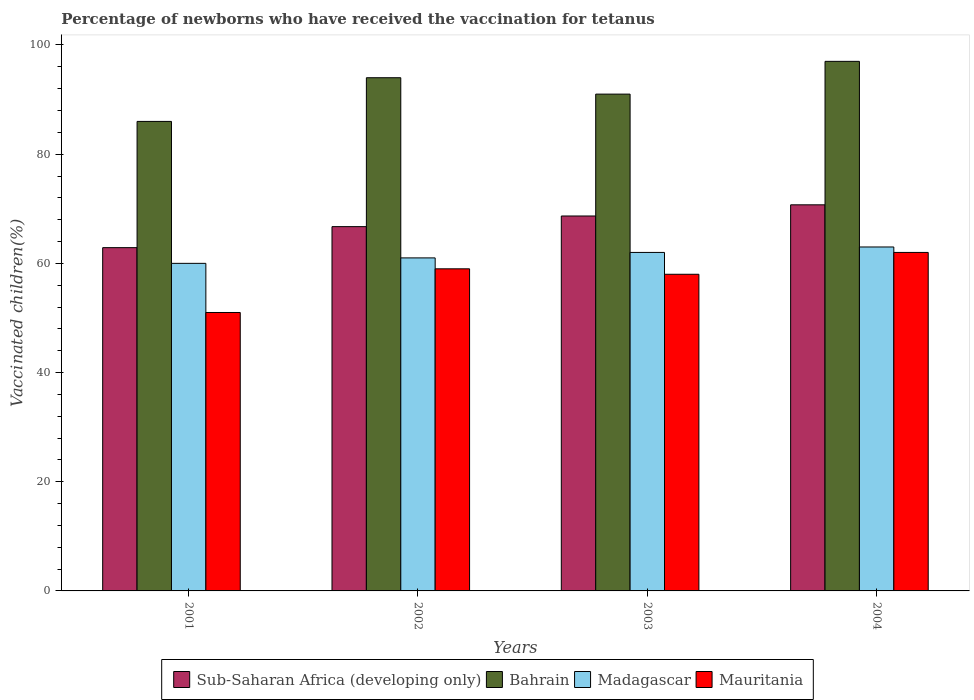How many different coloured bars are there?
Offer a very short reply. 4. How many groups of bars are there?
Offer a terse response. 4. Are the number of bars per tick equal to the number of legend labels?
Your response must be concise. Yes. Are the number of bars on each tick of the X-axis equal?
Offer a very short reply. Yes. How many bars are there on the 1st tick from the left?
Your response must be concise. 4. What is the percentage of vaccinated children in Mauritania in 2004?
Keep it short and to the point. 62. Across all years, what is the maximum percentage of vaccinated children in Madagascar?
Your answer should be compact. 63. Across all years, what is the minimum percentage of vaccinated children in Madagascar?
Your response must be concise. 60. In which year was the percentage of vaccinated children in Sub-Saharan Africa (developing only) maximum?
Your answer should be compact. 2004. What is the total percentage of vaccinated children in Madagascar in the graph?
Your answer should be compact. 246. What is the difference between the percentage of vaccinated children in Sub-Saharan Africa (developing only) in 2001 and that in 2003?
Your response must be concise. -5.8. What is the difference between the percentage of vaccinated children in Bahrain in 2003 and the percentage of vaccinated children in Madagascar in 2001?
Provide a succinct answer. 31. What is the average percentage of vaccinated children in Bahrain per year?
Ensure brevity in your answer.  92. In the year 2003, what is the difference between the percentage of vaccinated children in Sub-Saharan Africa (developing only) and percentage of vaccinated children in Mauritania?
Give a very brief answer. 10.68. What is the ratio of the percentage of vaccinated children in Sub-Saharan Africa (developing only) in 2002 to that in 2003?
Make the answer very short. 0.97. Is the percentage of vaccinated children in Bahrain in 2002 less than that in 2003?
Your answer should be very brief. No. Is the difference between the percentage of vaccinated children in Sub-Saharan Africa (developing only) in 2001 and 2004 greater than the difference between the percentage of vaccinated children in Mauritania in 2001 and 2004?
Make the answer very short. Yes. What is the difference between the highest and the lowest percentage of vaccinated children in Mauritania?
Offer a terse response. 11. In how many years, is the percentage of vaccinated children in Bahrain greater than the average percentage of vaccinated children in Bahrain taken over all years?
Your answer should be compact. 2. Is the sum of the percentage of vaccinated children in Madagascar in 2003 and 2004 greater than the maximum percentage of vaccinated children in Bahrain across all years?
Ensure brevity in your answer.  Yes. What does the 3rd bar from the left in 2001 represents?
Keep it short and to the point. Madagascar. What does the 4th bar from the right in 2002 represents?
Your answer should be very brief. Sub-Saharan Africa (developing only). Is it the case that in every year, the sum of the percentage of vaccinated children in Madagascar and percentage of vaccinated children in Bahrain is greater than the percentage of vaccinated children in Mauritania?
Give a very brief answer. Yes. Are all the bars in the graph horizontal?
Offer a terse response. No. What is the difference between two consecutive major ticks on the Y-axis?
Provide a succinct answer. 20. Are the values on the major ticks of Y-axis written in scientific E-notation?
Provide a succinct answer. No. Does the graph contain any zero values?
Make the answer very short. No. Does the graph contain grids?
Offer a terse response. No. How are the legend labels stacked?
Keep it short and to the point. Horizontal. What is the title of the graph?
Make the answer very short. Percentage of newborns who have received the vaccination for tetanus. Does "Kosovo" appear as one of the legend labels in the graph?
Provide a short and direct response. No. What is the label or title of the Y-axis?
Your answer should be very brief. Vaccinated children(%). What is the Vaccinated children(%) of Sub-Saharan Africa (developing only) in 2001?
Offer a terse response. 62.88. What is the Vaccinated children(%) in Madagascar in 2001?
Offer a terse response. 60. What is the Vaccinated children(%) of Sub-Saharan Africa (developing only) in 2002?
Your answer should be very brief. 66.73. What is the Vaccinated children(%) in Bahrain in 2002?
Your answer should be compact. 94. What is the Vaccinated children(%) of Madagascar in 2002?
Give a very brief answer. 61. What is the Vaccinated children(%) of Mauritania in 2002?
Provide a succinct answer. 59. What is the Vaccinated children(%) in Sub-Saharan Africa (developing only) in 2003?
Offer a very short reply. 68.68. What is the Vaccinated children(%) in Bahrain in 2003?
Your answer should be very brief. 91. What is the Vaccinated children(%) of Sub-Saharan Africa (developing only) in 2004?
Your answer should be compact. 70.72. What is the Vaccinated children(%) in Bahrain in 2004?
Provide a short and direct response. 97. What is the Vaccinated children(%) in Mauritania in 2004?
Give a very brief answer. 62. Across all years, what is the maximum Vaccinated children(%) in Sub-Saharan Africa (developing only)?
Your response must be concise. 70.72. Across all years, what is the maximum Vaccinated children(%) of Bahrain?
Provide a short and direct response. 97. Across all years, what is the minimum Vaccinated children(%) in Sub-Saharan Africa (developing only)?
Give a very brief answer. 62.88. Across all years, what is the minimum Vaccinated children(%) in Bahrain?
Provide a succinct answer. 86. Across all years, what is the minimum Vaccinated children(%) of Madagascar?
Provide a succinct answer. 60. Across all years, what is the minimum Vaccinated children(%) of Mauritania?
Provide a short and direct response. 51. What is the total Vaccinated children(%) of Sub-Saharan Africa (developing only) in the graph?
Provide a short and direct response. 269. What is the total Vaccinated children(%) of Bahrain in the graph?
Ensure brevity in your answer.  368. What is the total Vaccinated children(%) in Madagascar in the graph?
Keep it short and to the point. 246. What is the total Vaccinated children(%) in Mauritania in the graph?
Your answer should be compact. 230. What is the difference between the Vaccinated children(%) in Sub-Saharan Africa (developing only) in 2001 and that in 2002?
Ensure brevity in your answer.  -3.85. What is the difference between the Vaccinated children(%) of Sub-Saharan Africa (developing only) in 2001 and that in 2003?
Give a very brief answer. -5.8. What is the difference between the Vaccinated children(%) in Bahrain in 2001 and that in 2003?
Offer a very short reply. -5. What is the difference between the Vaccinated children(%) in Mauritania in 2001 and that in 2003?
Your answer should be very brief. -7. What is the difference between the Vaccinated children(%) of Sub-Saharan Africa (developing only) in 2001 and that in 2004?
Keep it short and to the point. -7.84. What is the difference between the Vaccinated children(%) of Madagascar in 2001 and that in 2004?
Provide a short and direct response. -3. What is the difference between the Vaccinated children(%) of Mauritania in 2001 and that in 2004?
Provide a succinct answer. -11. What is the difference between the Vaccinated children(%) in Sub-Saharan Africa (developing only) in 2002 and that in 2003?
Your response must be concise. -1.95. What is the difference between the Vaccinated children(%) in Bahrain in 2002 and that in 2003?
Give a very brief answer. 3. What is the difference between the Vaccinated children(%) of Madagascar in 2002 and that in 2003?
Your answer should be very brief. -1. What is the difference between the Vaccinated children(%) of Sub-Saharan Africa (developing only) in 2002 and that in 2004?
Your answer should be compact. -3.99. What is the difference between the Vaccinated children(%) of Sub-Saharan Africa (developing only) in 2003 and that in 2004?
Keep it short and to the point. -2.04. What is the difference between the Vaccinated children(%) of Bahrain in 2003 and that in 2004?
Your response must be concise. -6. What is the difference between the Vaccinated children(%) of Sub-Saharan Africa (developing only) in 2001 and the Vaccinated children(%) of Bahrain in 2002?
Give a very brief answer. -31.12. What is the difference between the Vaccinated children(%) in Sub-Saharan Africa (developing only) in 2001 and the Vaccinated children(%) in Madagascar in 2002?
Your answer should be compact. 1.88. What is the difference between the Vaccinated children(%) of Sub-Saharan Africa (developing only) in 2001 and the Vaccinated children(%) of Mauritania in 2002?
Offer a terse response. 3.88. What is the difference between the Vaccinated children(%) in Sub-Saharan Africa (developing only) in 2001 and the Vaccinated children(%) in Bahrain in 2003?
Keep it short and to the point. -28.12. What is the difference between the Vaccinated children(%) in Sub-Saharan Africa (developing only) in 2001 and the Vaccinated children(%) in Madagascar in 2003?
Give a very brief answer. 0.88. What is the difference between the Vaccinated children(%) of Sub-Saharan Africa (developing only) in 2001 and the Vaccinated children(%) of Mauritania in 2003?
Provide a short and direct response. 4.88. What is the difference between the Vaccinated children(%) of Sub-Saharan Africa (developing only) in 2001 and the Vaccinated children(%) of Bahrain in 2004?
Keep it short and to the point. -34.12. What is the difference between the Vaccinated children(%) in Sub-Saharan Africa (developing only) in 2001 and the Vaccinated children(%) in Madagascar in 2004?
Provide a succinct answer. -0.12. What is the difference between the Vaccinated children(%) of Sub-Saharan Africa (developing only) in 2001 and the Vaccinated children(%) of Mauritania in 2004?
Your answer should be very brief. 0.88. What is the difference between the Vaccinated children(%) of Bahrain in 2001 and the Vaccinated children(%) of Madagascar in 2004?
Make the answer very short. 23. What is the difference between the Vaccinated children(%) in Madagascar in 2001 and the Vaccinated children(%) in Mauritania in 2004?
Make the answer very short. -2. What is the difference between the Vaccinated children(%) of Sub-Saharan Africa (developing only) in 2002 and the Vaccinated children(%) of Bahrain in 2003?
Your response must be concise. -24.27. What is the difference between the Vaccinated children(%) of Sub-Saharan Africa (developing only) in 2002 and the Vaccinated children(%) of Madagascar in 2003?
Make the answer very short. 4.73. What is the difference between the Vaccinated children(%) in Sub-Saharan Africa (developing only) in 2002 and the Vaccinated children(%) in Mauritania in 2003?
Offer a very short reply. 8.73. What is the difference between the Vaccinated children(%) in Bahrain in 2002 and the Vaccinated children(%) in Madagascar in 2003?
Provide a short and direct response. 32. What is the difference between the Vaccinated children(%) of Madagascar in 2002 and the Vaccinated children(%) of Mauritania in 2003?
Keep it short and to the point. 3. What is the difference between the Vaccinated children(%) of Sub-Saharan Africa (developing only) in 2002 and the Vaccinated children(%) of Bahrain in 2004?
Your answer should be compact. -30.27. What is the difference between the Vaccinated children(%) of Sub-Saharan Africa (developing only) in 2002 and the Vaccinated children(%) of Madagascar in 2004?
Make the answer very short. 3.73. What is the difference between the Vaccinated children(%) of Sub-Saharan Africa (developing only) in 2002 and the Vaccinated children(%) of Mauritania in 2004?
Ensure brevity in your answer.  4.73. What is the difference between the Vaccinated children(%) in Bahrain in 2002 and the Vaccinated children(%) in Madagascar in 2004?
Your response must be concise. 31. What is the difference between the Vaccinated children(%) of Bahrain in 2002 and the Vaccinated children(%) of Mauritania in 2004?
Your answer should be very brief. 32. What is the difference between the Vaccinated children(%) of Sub-Saharan Africa (developing only) in 2003 and the Vaccinated children(%) of Bahrain in 2004?
Give a very brief answer. -28.32. What is the difference between the Vaccinated children(%) of Sub-Saharan Africa (developing only) in 2003 and the Vaccinated children(%) of Madagascar in 2004?
Offer a very short reply. 5.68. What is the difference between the Vaccinated children(%) in Sub-Saharan Africa (developing only) in 2003 and the Vaccinated children(%) in Mauritania in 2004?
Your response must be concise. 6.68. What is the difference between the Vaccinated children(%) of Bahrain in 2003 and the Vaccinated children(%) of Mauritania in 2004?
Keep it short and to the point. 29. What is the average Vaccinated children(%) in Sub-Saharan Africa (developing only) per year?
Provide a short and direct response. 67.25. What is the average Vaccinated children(%) in Bahrain per year?
Give a very brief answer. 92. What is the average Vaccinated children(%) in Madagascar per year?
Make the answer very short. 61.5. What is the average Vaccinated children(%) of Mauritania per year?
Provide a succinct answer. 57.5. In the year 2001, what is the difference between the Vaccinated children(%) in Sub-Saharan Africa (developing only) and Vaccinated children(%) in Bahrain?
Your answer should be very brief. -23.12. In the year 2001, what is the difference between the Vaccinated children(%) of Sub-Saharan Africa (developing only) and Vaccinated children(%) of Madagascar?
Provide a short and direct response. 2.88. In the year 2001, what is the difference between the Vaccinated children(%) in Sub-Saharan Africa (developing only) and Vaccinated children(%) in Mauritania?
Provide a succinct answer. 11.88. In the year 2001, what is the difference between the Vaccinated children(%) in Bahrain and Vaccinated children(%) in Mauritania?
Keep it short and to the point. 35. In the year 2002, what is the difference between the Vaccinated children(%) of Sub-Saharan Africa (developing only) and Vaccinated children(%) of Bahrain?
Offer a terse response. -27.27. In the year 2002, what is the difference between the Vaccinated children(%) in Sub-Saharan Africa (developing only) and Vaccinated children(%) in Madagascar?
Provide a succinct answer. 5.73. In the year 2002, what is the difference between the Vaccinated children(%) of Sub-Saharan Africa (developing only) and Vaccinated children(%) of Mauritania?
Keep it short and to the point. 7.73. In the year 2002, what is the difference between the Vaccinated children(%) of Bahrain and Vaccinated children(%) of Madagascar?
Offer a very short reply. 33. In the year 2002, what is the difference between the Vaccinated children(%) of Madagascar and Vaccinated children(%) of Mauritania?
Offer a terse response. 2. In the year 2003, what is the difference between the Vaccinated children(%) of Sub-Saharan Africa (developing only) and Vaccinated children(%) of Bahrain?
Provide a short and direct response. -22.32. In the year 2003, what is the difference between the Vaccinated children(%) of Sub-Saharan Africa (developing only) and Vaccinated children(%) of Madagascar?
Give a very brief answer. 6.68. In the year 2003, what is the difference between the Vaccinated children(%) in Sub-Saharan Africa (developing only) and Vaccinated children(%) in Mauritania?
Keep it short and to the point. 10.68. In the year 2003, what is the difference between the Vaccinated children(%) of Bahrain and Vaccinated children(%) of Madagascar?
Your answer should be very brief. 29. In the year 2003, what is the difference between the Vaccinated children(%) of Bahrain and Vaccinated children(%) of Mauritania?
Your response must be concise. 33. In the year 2003, what is the difference between the Vaccinated children(%) in Madagascar and Vaccinated children(%) in Mauritania?
Ensure brevity in your answer.  4. In the year 2004, what is the difference between the Vaccinated children(%) of Sub-Saharan Africa (developing only) and Vaccinated children(%) of Bahrain?
Provide a succinct answer. -26.28. In the year 2004, what is the difference between the Vaccinated children(%) in Sub-Saharan Africa (developing only) and Vaccinated children(%) in Madagascar?
Provide a succinct answer. 7.72. In the year 2004, what is the difference between the Vaccinated children(%) in Sub-Saharan Africa (developing only) and Vaccinated children(%) in Mauritania?
Ensure brevity in your answer.  8.72. In the year 2004, what is the difference between the Vaccinated children(%) in Bahrain and Vaccinated children(%) in Madagascar?
Offer a terse response. 34. In the year 2004, what is the difference between the Vaccinated children(%) in Bahrain and Vaccinated children(%) in Mauritania?
Ensure brevity in your answer.  35. In the year 2004, what is the difference between the Vaccinated children(%) in Madagascar and Vaccinated children(%) in Mauritania?
Your answer should be compact. 1. What is the ratio of the Vaccinated children(%) of Sub-Saharan Africa (developing only) in 2001 to that in 2002?
Your response must be concise. 0.94. What is the ratio of the Vaccinated children(%) of Bahrain in 2001 to that in 2002?
Keep it short and to the point. 0.91. What is the ratio of the Vaccinated children(%) of Madagascar in 2001 to that in 2002?
Offer a terse response. 0.98. What is the ratio of the Vaccinated children(%) in Mauritania in 2001 to that in 2002?
Your answer should be very brief. 0.86. What is the ratio of the Vaccinated children(%) of Sub-Saharan Africa (developing only) in 2001 to that in 2003?
Your answer should be very brief. 0.92. What is the ratio of the Vaccinated children(%) of Bahrain in 2001 to that in 2003?
Your answer should be compact. 0.95. What is the ratio of the Vaccinated children(%) of Mauritania in 2001 to that in 2003?
Offer a terse response. 0.88. What is the ratio of the Vaccinated children(%) in Sub-Saharan Africa (developing only) in 2001 to that in 2004?
Give a very brief answer. 0.89. What is the ratio of the Vaccinated children(%) in Bahrain in 2001 to that in 2004?
Offer a very short reply. 0.89. What is the ratio of the Vaccinated children(%) of Mauritania in 2001 to that in 2004?
Your answer should be very brief. 0.82. What is the ratio of the Vaccinated children(%) in Sub-Saharan Africa (developing only) in 2002 to that in 2003?
Offer a very short reply. 0.97. What is the ratio of the Vaccinated children(%) in Bahrain in 2002 to that in 2003?
Ensure brevity in your answer.  1.03. What is the ratio of the Vaccinated children(%) of Madagascar in 2002 to that in 2003?
Your answer should be very brief. 0.98. What is the ratio of the Vaccinated children(%) of Mauritania in 2002 to that in 2003?
Offer a terse response. 1.02. What is the ratio of the Vaccinated children(%) of Sub-Saharan Africa (developing only) in 2002 to that in 2004?
Offer a very short reply. 0.94. What is the ratio of the Vaccinated children(%) in Bahrain in 2002 to that in 2004?
Your response must be concise. 0.97. What is the ratio of the Vaccinated children(%) of Madagascar in 2002 to that in 2004?
Make the answer very short. 0.97. What is the ratio of the Vaccinated children(%) of Mauritania in 2002 to that in 2004?
Your answer should be very brief. 0.95. What is the ratio of the Vaccinated children(%) in Sub-Saharan Africa (developing only) in 2003 to that in 2004?
Provide a succinct answer. 0.97. What is the ratio of the Vaccinated children(%) of Bahrain in 2003 to that in 2004?
Make the answer very short. 0.94. What is the ratio of the Vaccinated children(%) of Madagascar in 2003 to that in 2004?
Keep it short and to the point. 0.98. What is the ratio of the Vaccinated children(%) in Mauritania in 2003 to that in 2004?
Your answer should be very brief. 0.94. What is the difference between the highest and the second highest Vaccinated children(%) of Sub-Saharan Africa (developing only)?
Offer a terse response. 2.04. What is the difference between the highest and the second highest Vaccinated children(%) in Bahrain?
Your response must be concise. 3. What is the difference between the highest and the second highest Vaccinated children(%) of Madagascar?
Offer a terse response. 1. What is the difference between the highest and the second highest Vaccinated children(%) in Mauritania?
Offer a terse response. 3. What is the difference between the highest and the lowest Vaccinated children(%) in Sub-Saharan Africa (developing only)?
Provide a succinct answer. 7.84. What is the difference between the highest and the lowest Vaccinated children(%) in Madagascar?
Your response must be concise. 3. What is the difference between the highest and the lowest Vaccinated children(%) of Mauritania?
Ensure brevity in your answer.  11. 